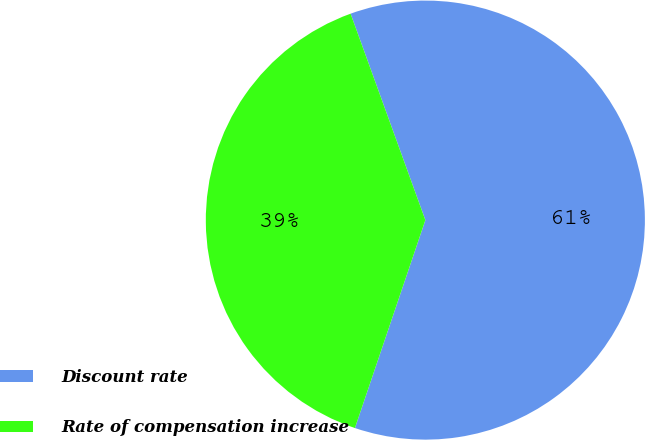Convert chart to OTSL. <chart><loc_0><loc_0><loc_500><loc_500><pie_chart><fcel>Discount rate<fcel>Rate of compensation increase<nl><fcel>60.73%<fcel>39.27%<nl></chart> 